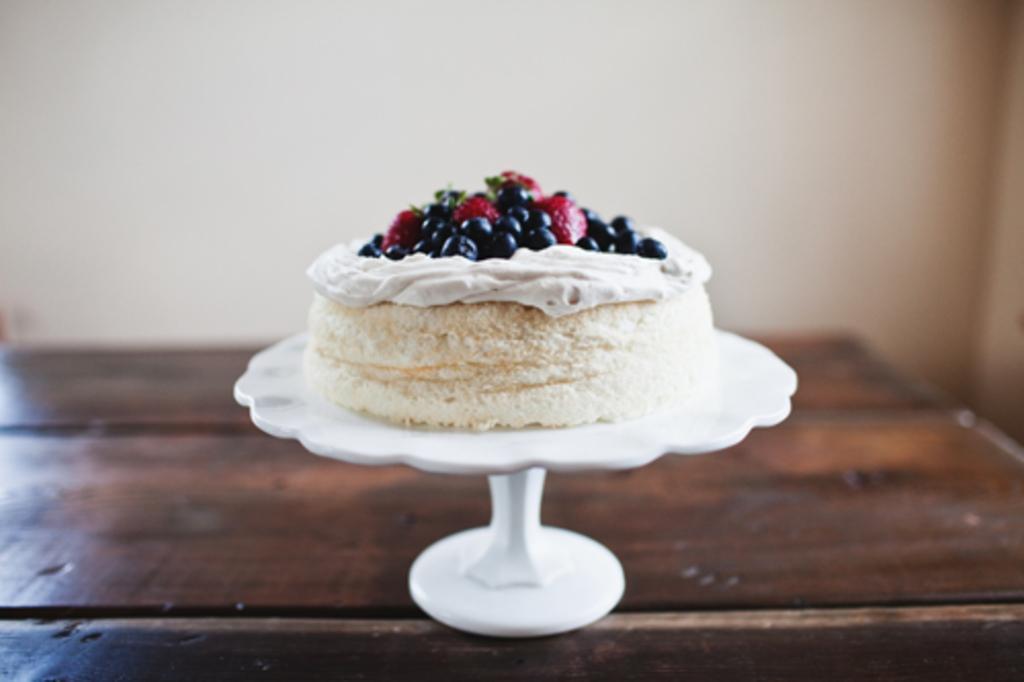How would you summarize this image in a sentence or two? This picture is taken inside the room. In the image, we can see a table, on that table, we can see a stand, on that stand, we can see a cake. In the background, we can see a wall. 